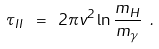Convert formula to latex. <formula><loc_0><loc_0><loc_500><loc_500>\tau _ { I I } \ = \ 2 \pi v ^ { 2 } \ln \frac { m _ { H } } { m _ { \gamma } } \ .</formula> 